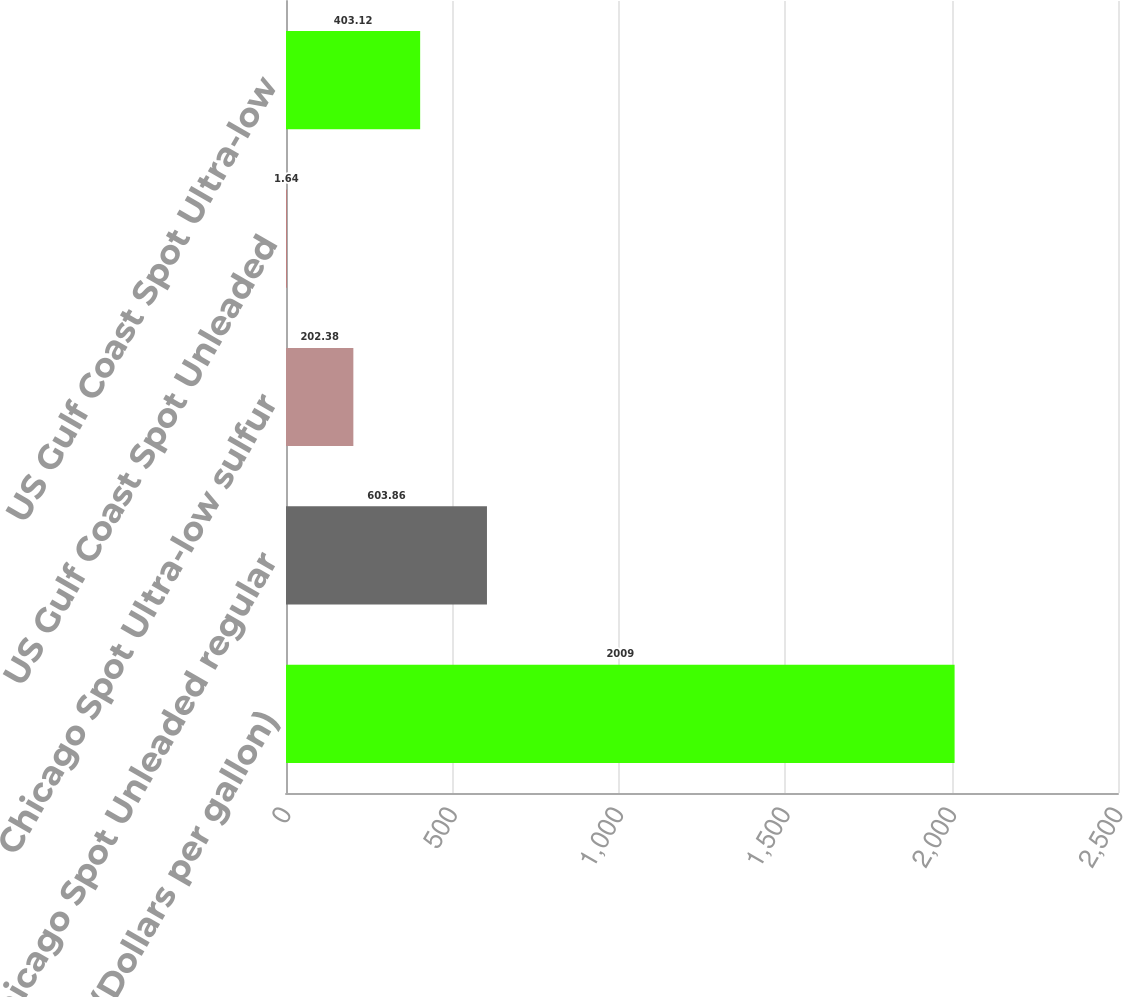Convert chart. <chart><loc_0><loc_0><loc_500><loc_500><bar_chart><fcel>(Dollars per gallon)<fcel>Chicago Spot Unleaded regular<fcel>Chicago Spot Ultra-low sulfur<fcel>US Gulf Coast Spot Unleaded<fcel>US Gulf Coast Spot Ultra-low<nl><fcel>2009<fcel>603.86<fcel>202.38<fcel>1.64<fcel>403.12<nl></chart> 